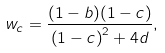<formula> <loc_0><loc_0><loc_500><loc_500>w _ { c } = \frac { ( 1 - b ) ( 1 - c ) } { \left ( 1 - c \right ) ^ { 2 } + 4 d } ,</formula> 